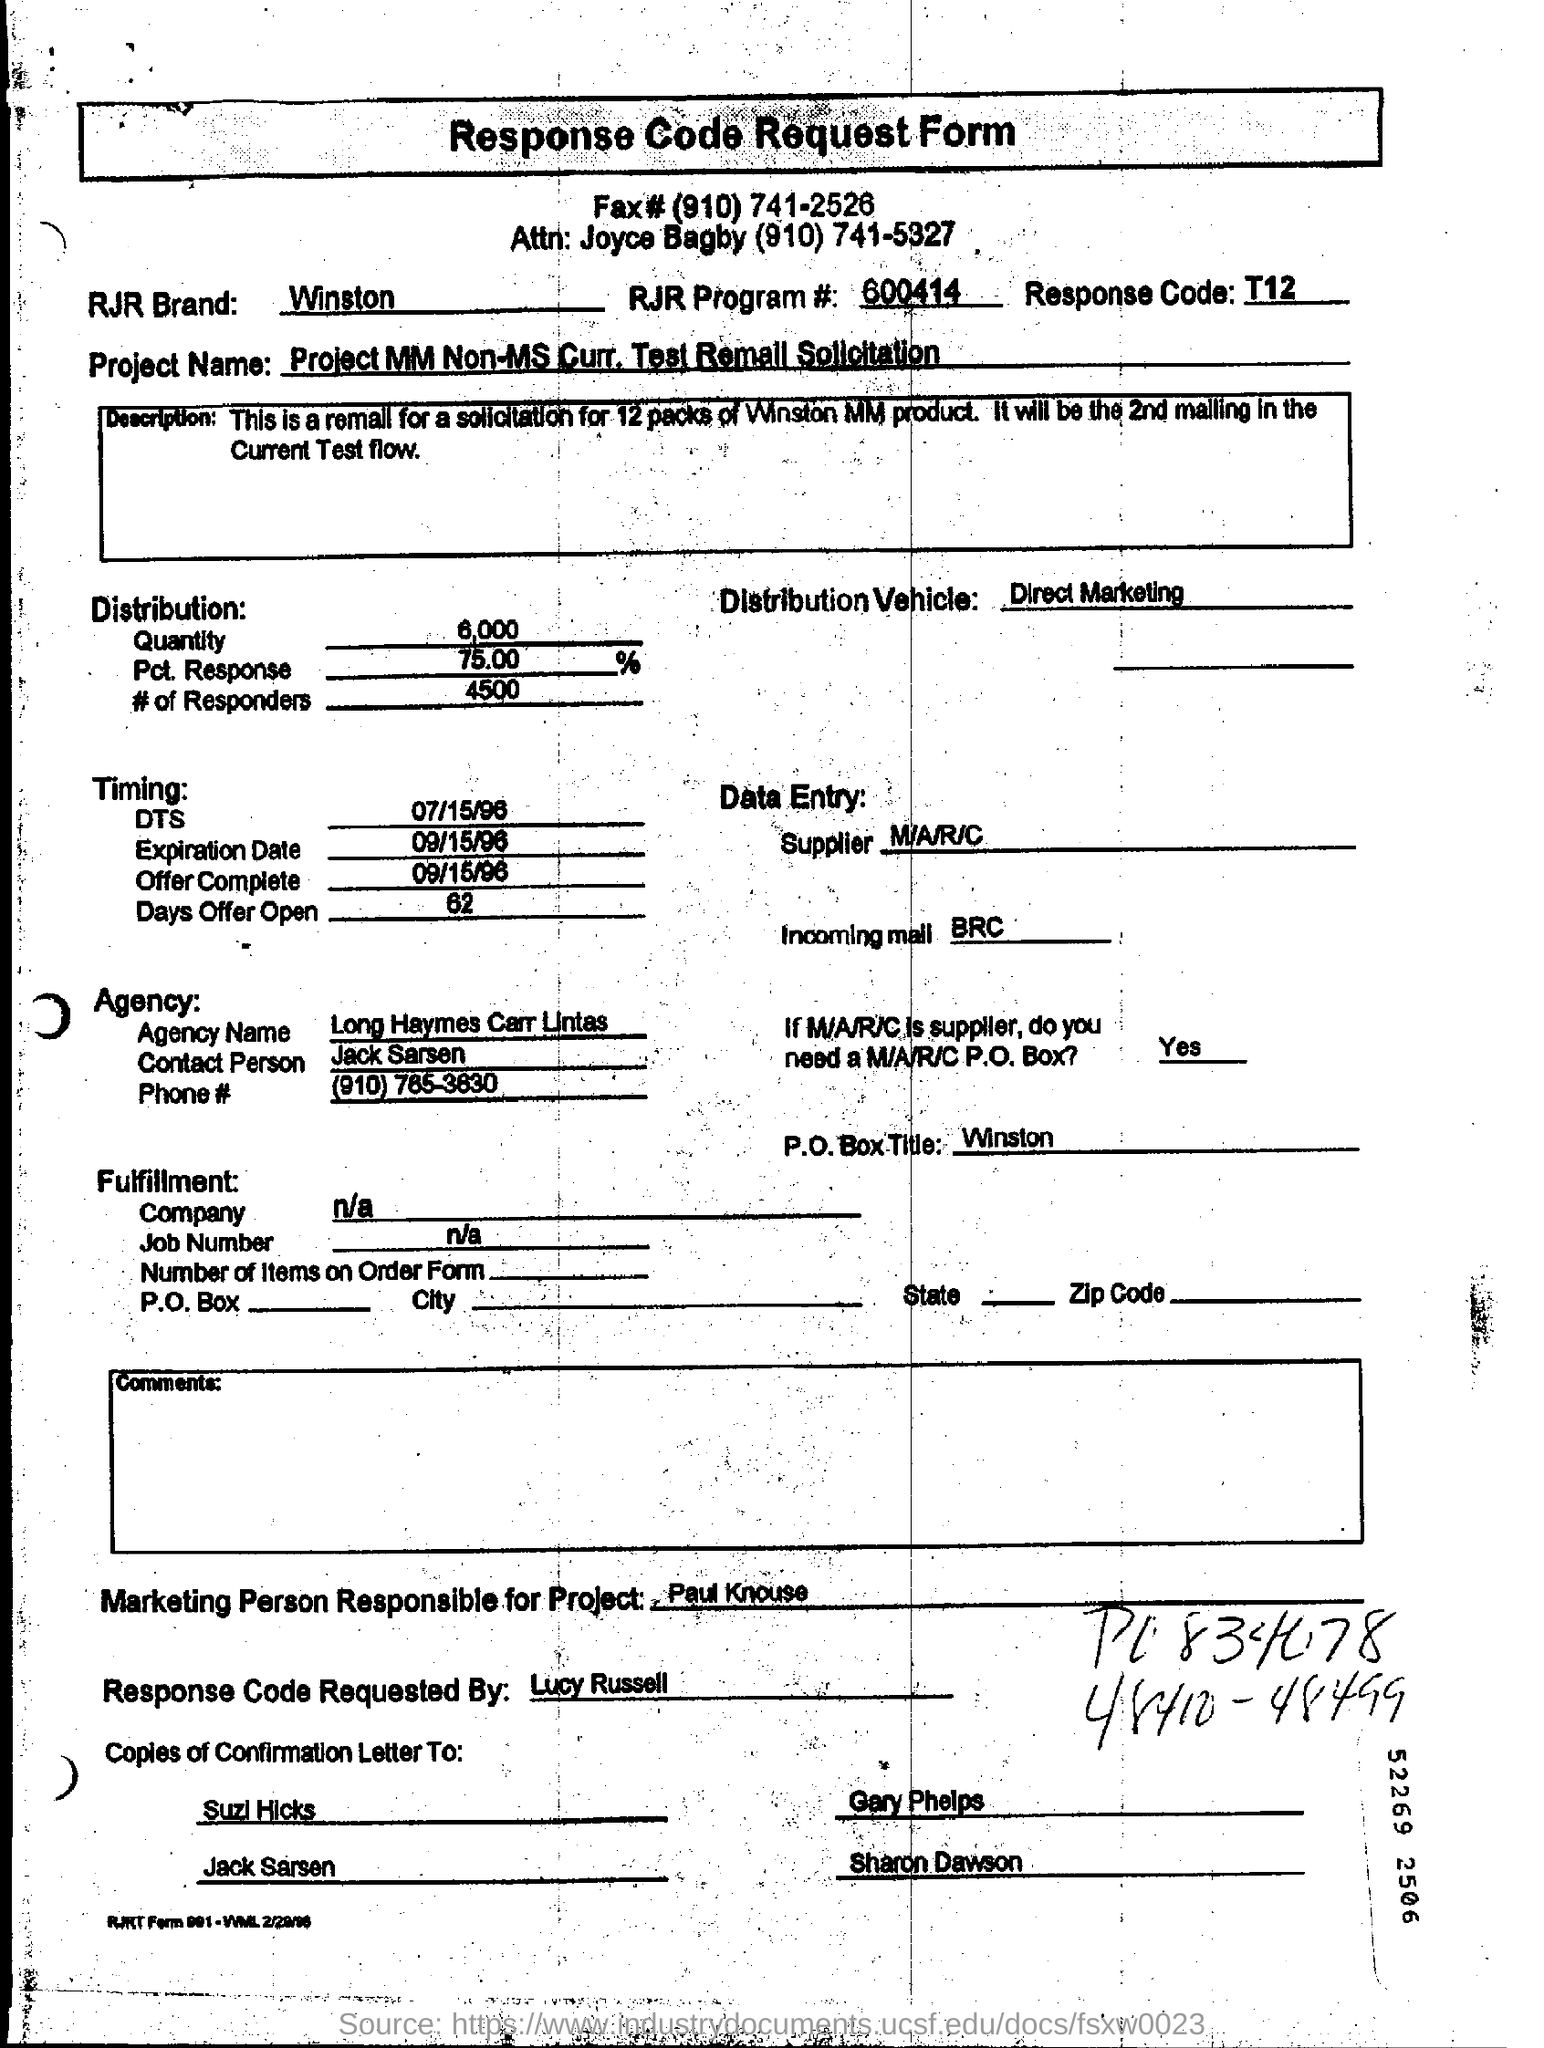Give some essential details in this illustration. The contact person at the agency is named Jack Sarsen. The name of the project is "MM Non-MS curr. test remail solicitation. The name of the agency is Long Haymes Carr Lintas. 